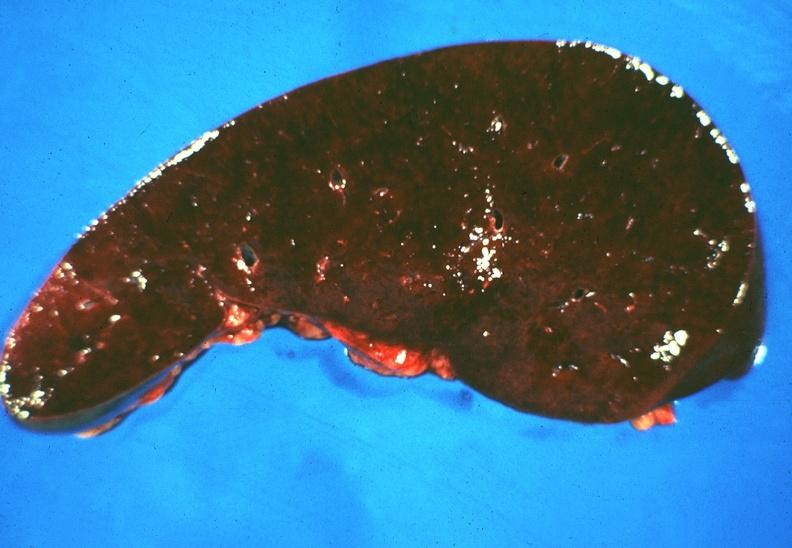what does this image show?
Answer the question using a single word or phrase. Spleen 